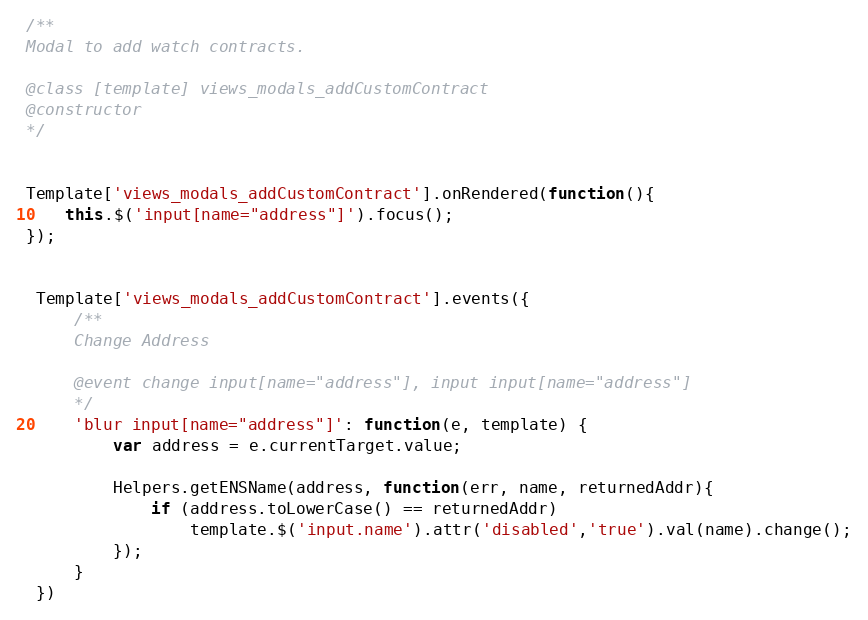<code> <loc_0><loc_0><loc_500><loc_500><_JavaScript_>/**
Modal to add watch contracts.

@class [template] views_modals_addCustomContract
@constructor
*/


Template['views_modals_addCustomContract'].onRendered(function(){
    this.$('input[name="address"]').focus();
});


 Template['views_modals_addCustomContract'].events({
     /**
     Change Address
 
     @event change input[name="address"], input input[name="address"]
     */
     'blur input[name="address"]': function(e, template) {
         var address = e.currentTarget.value;
 
         Helpers.getENSName(address, function(err, name, returnedAddr){
             if (address.toLowerCase() == returnedAddr)
                 template.$('input.name').attr('disabled','true').val(name).change();
         });
     }
 })</code> 